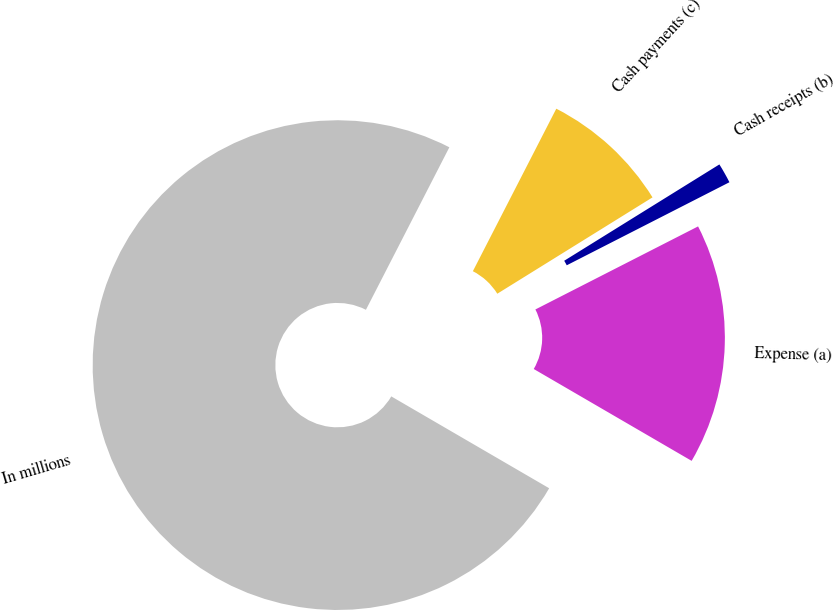Convert chart to OTSL. <chart><loc_0><loc_0><loc_500><loc_500><pie_chart><fcel>In millions<fcel>Expense (a)<fcel>Cash receipts (b)<fcel>Cash payments (c)<nl><fcel>74.17%<fcel>15.9%<fcel>1.33%<fcel>8.61%<nl></chart> 